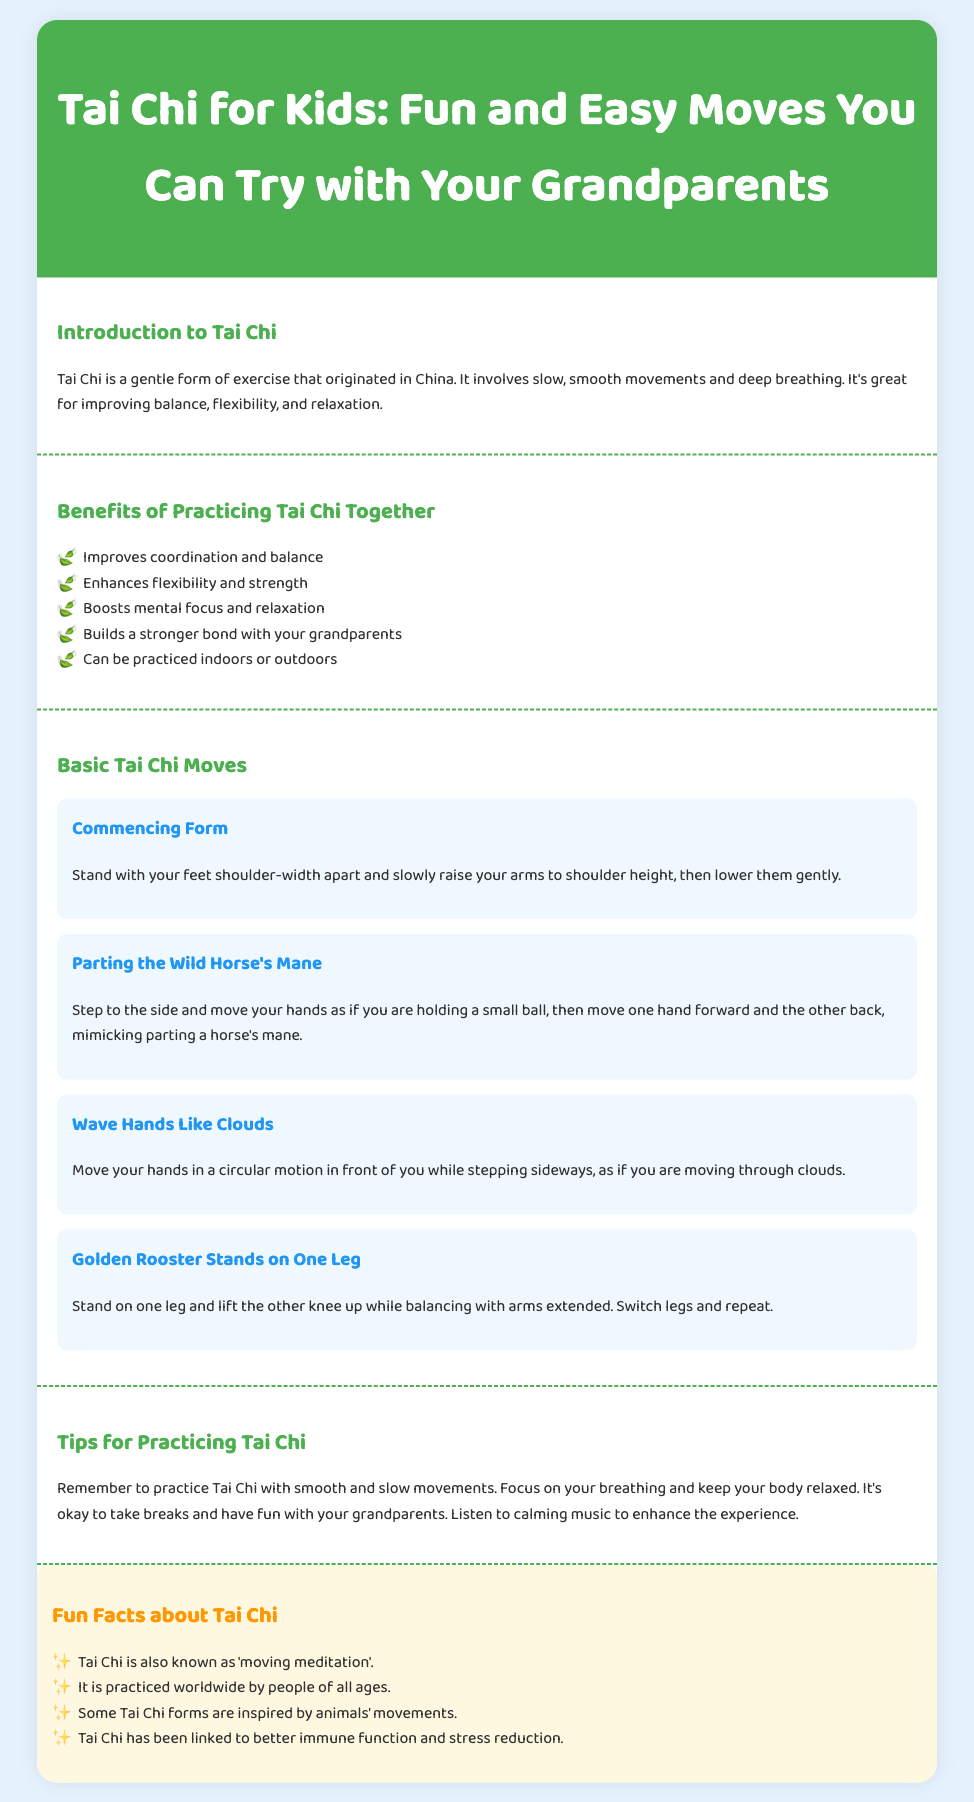what is Tai Chi? Tai Chi is described as a gentle form of exercise that originated in China, involving slow, smooth movements and deep breathing.
Answer: a gentle form of exercise what is one benefit of practicing Tai Chi together? The benefits section lists various advantages; one of them is enhancing flexibility and strength.
Answer: enhances flexibility and strength how many basic Tai Chi moves are listed? The section on Basic Tai Chi Moves describes four distinct moves.
Answer: four what is the first basic Tai Chi move mentioned? The first movement listed under Basic Tai Chi Moves is Commencing Form.
Answer: Commencing Form what should you remember while practicing Tai Chi? The tips section advises to practice with smooth and slow movements, and focus on breathing.
Answer: smooth and slow movements what is a fun fact about Tai Chi? One fun fact stated is that Tai Chi is also known as 'moving meditation'.
Answer: 'moving meditation' what is the color of the background in the document? The background color of the body is specified as light blue (#E6F3FF).
Answer: light blue how does Tai Chi benefit bonding? One of the benefits of practicing Tai Chi together is that it builds a stronger bond with your grandparents.
Answer: builds a stronger bond with your grandparents 